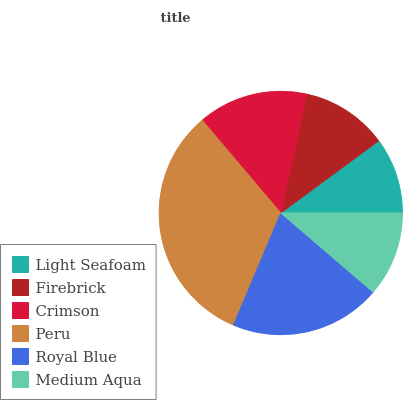Is Light Seafoam the minimum?
Answer yes or no. Yes. Is Peru the maximum?
Answer yes or no. Yes. Is Firebrick the minimum?
Answer yes or no. No. Is Firebrick the maximum?
Answer yes or no. No. Is Firebrick greater than Light Seafoam?
Answer yes or no. Yes. Is Light Seafoam less than Firebrick?
Answer yes or no. Yes. Is Light Seafoam greater than Firebrick?
Answer yes or no. No. Is Firebrick less than Light Seafoam?
Answer yes or no. No. Is Crimson the high median?
Answer yes or no. Yes. Is Firebrick the low median?
Answer yes or no. Yes. Is Light Seafoam the high median?
Answer yes or no. No. Is Light Seafoam the low median?
Answer yes or no. No. 